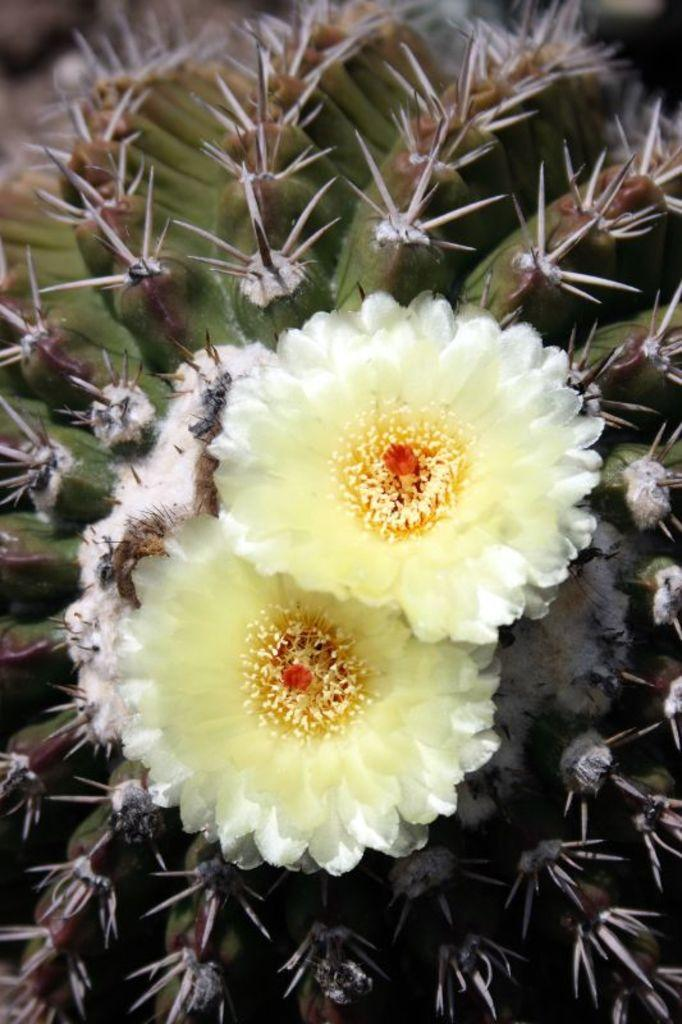What type of flowers can be seen in the image? There are white color flowers in the image. Can you describe the background of the image? There are stems in the background of the image. How many children are present in the image? There are no children present in the image; it only features white color flowers and stems. What type of degree is required to understand the image? There is no degree required to understand the image, as it is a simple depiction of white color flowers and stems. 